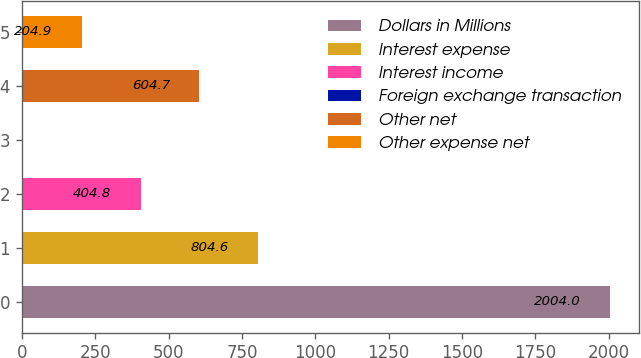Convert chart. <chart><loc_0><loc_0><loc_500><loc_500><bar_chart><fcel>Dollars in Millions<fcel>Interest expense<fcel>Interest income<fcel>Foreign exchange transaction<fcel>Other net<fcel>Other expense net<nl><fcel>2004<fcel>804.6<fcel>404.8<fcel>5<fcel>604.7<fcel>204.9<nl></chart> 